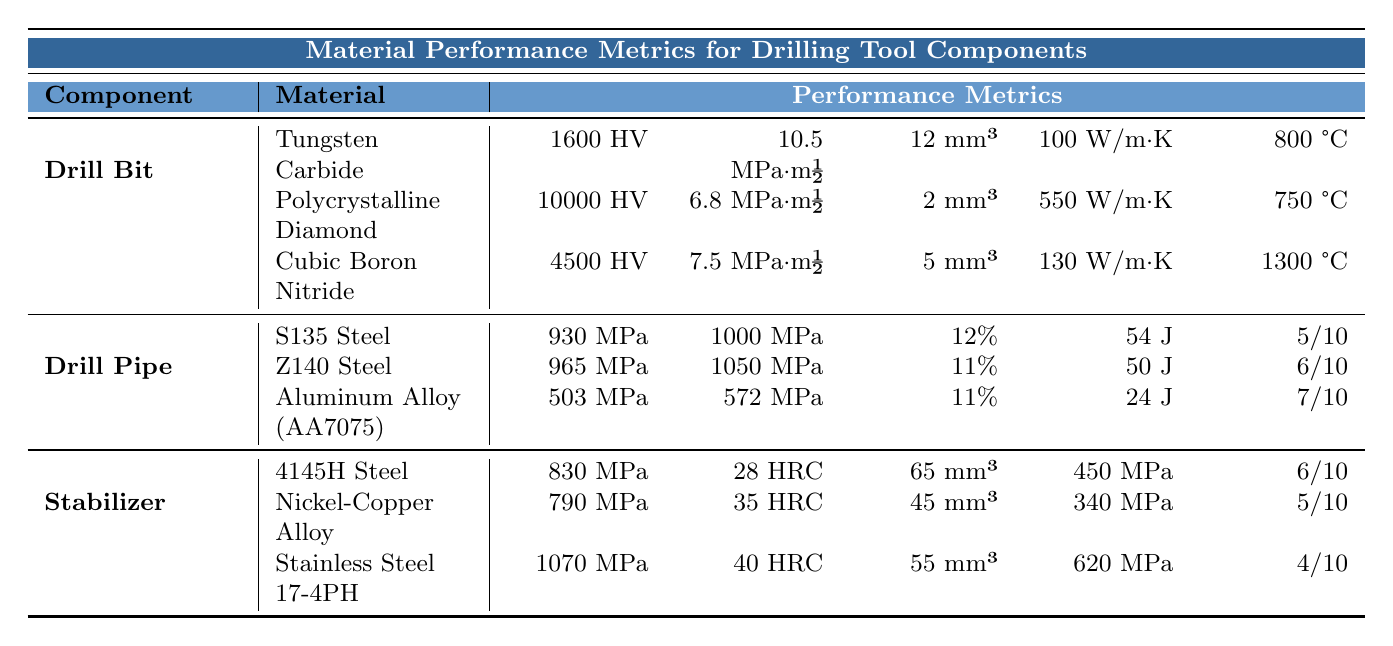What is the hardness of Polycrystalline Diamond? The table lists the performance metrics for various drill bit materials. For Polycrystalline Diamond, the hardness is specified as 10000 HV.
Answer: 10000 HV Which drill pipe material has the highest tensile strength? Checking the values under the drill pipe materials, Z140 Steel has the highest tensile strength at 1050 MPa.
Answer: Z140 Steel What is the wear resistance of Tungsten Carbide? The table indicates that Tungsten Carbide has a wear resistance of 12 mm³ according to the ASTM G65 volume loss measurement.
Answer: 12 mm³ Is the yield strength of 4145H Steel greater than that of S135 Steel? The table shows that 4145H Steel has a yield strength of 830 MPa, while S135 Steel has a yield strength of 930 MPa. Therefore, 4145H Steel's yield strength is less than S135 Steel's.
Answer: No What is the difference in yield strength between Stainless Steel 17-4PH and Nickel-Copper Alloy? The yield strength for Stainless Steel 17-4PH is 1070 MPa and for Nickel-Copper Alloy, it is 790 MPa. The difference is calculated as 1070 - 790 = 280 MPa.
Answer: 280 MPa Which material has the best thermal conductivity? Evaluating the thermal conductivity values provided, Polycrystalline Diamond has the highest value of 550 W/m·K compared to the other drill bit materials.
Answer: Polycrystalline Diamond What is the average elongation percentage of the drill pipe materials? The elongation percentages for S135 Steel (12%), Z140 Steel (11%), and Aluminum Alloy (11%) sum to 34%. Dividing this by the number of materials (3) gives an average of 34% / 3 = 11.33%.
Answer: 11.33% Which stabilizer material has the highest fatigue strength? The values from the table show that Stainless Steel 17-4PH has the highest fatigue strength at 620 MPa among the stabilizer materials listed.
Answer: Stainless Steel 17-4PH Are the wear resistances of Nickel-Copper Alloy and Stainless Steel 17-4PH the same? According to the table, Nickel-Copper Alloy has a wear resistance of 45 mm³ and Stainless Steel 17-4PH has a wear resistance of 55 mm³, indicating they are not the same.
Answer: No What is the maximum operating temperature of Cubic Boron Nitride? Looking at the metrics for Cubic Boron Nitride in the table, the maximum operating temperature is 1300 °C.
Answer: 1300 °C 